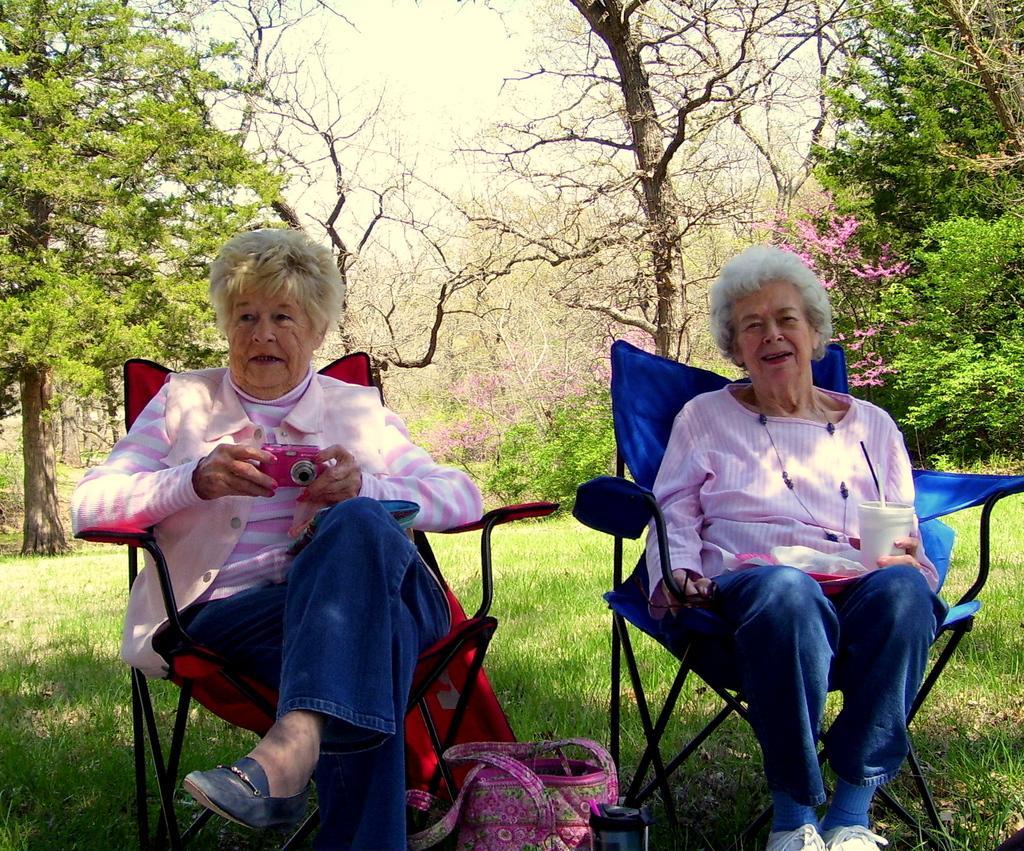Describe this image in one or two sentences. In this picture we can see two women sitting on chair where one is holding camera in her hand and other is holding glass straw in it and in between them we have bag, bottle and in background we can see trees. 